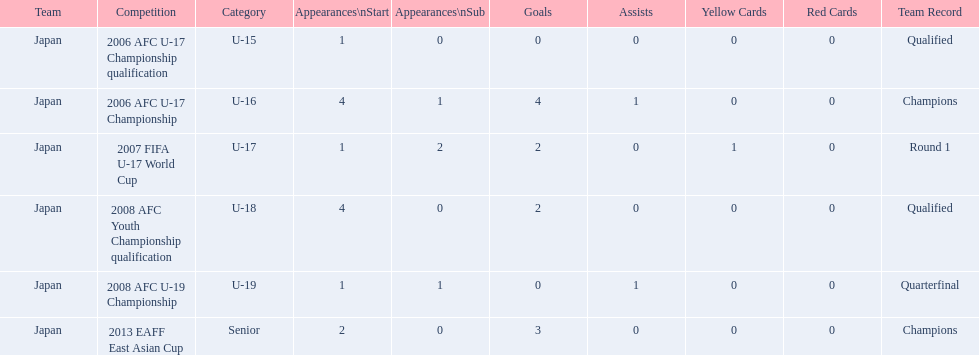What was the team record in 2006? Round 1. What competition did this belong too? 2006 AFC U-17 Championship. 